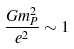Convert formula to latex. <formula><loc_0><loc_0><loc_500><loc_500>\frac { G m _ { P } ^ { 2 } } { e ^ { 2 } } \sim 1</formula> 